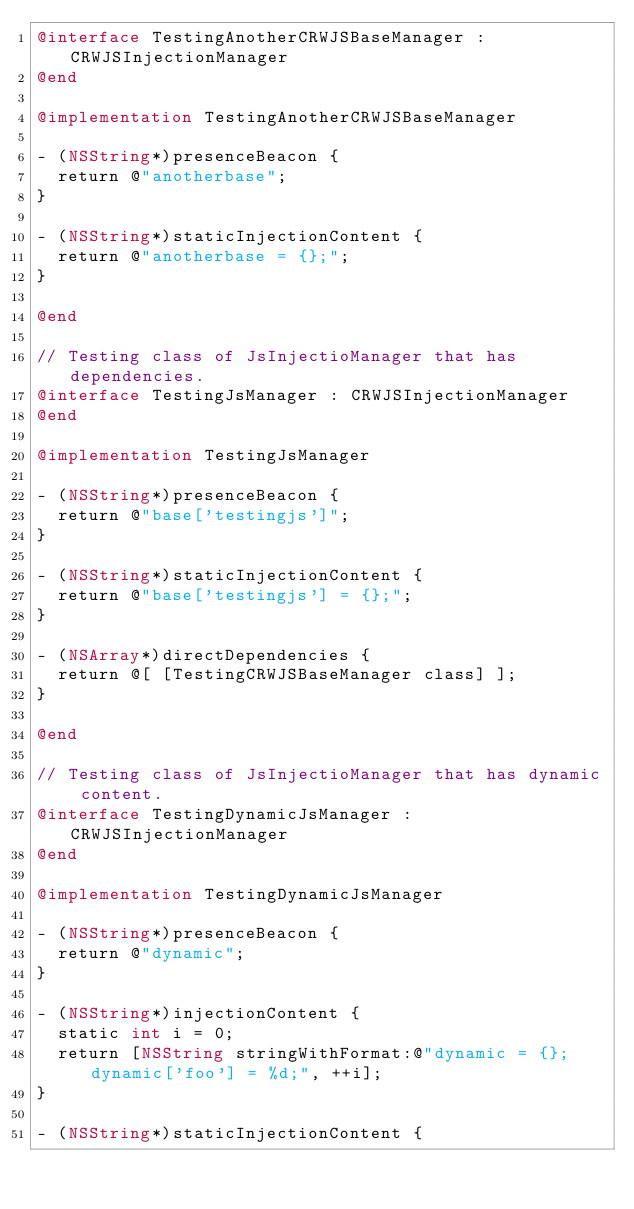Convert code to text. <code><loc_0><loc_0><loc_500><loc_500><_ObjectiveC_>@interface TestingAnotherCRWJSBaseManager : CRWJSInjectionManager
@end

@implementation TestingAnotherCRWJSBaseManager

- (NSString*)presenceBeacon {
  return @"anotherbase";
}

- (NSString*)staticInjectionContent {
  return @"anotherbase = {};";
}

@end

// Testing class of JsInjectioManager that has dependencies.
@interface TestingJsManager : CRWJSInjectionManager
@end

@implementation TestingJsManager

- (NSString*)presenceBeacon {
  return @"base['testingjs']";
}

- (NSString*)staticInjectionContent {
  return @"base['testingjs'] = {};";
}

- (NSArray*)directDependencies {
  return @[ [TestingCRWJSBaseManager class] ];
}

@end

// Testing class of JsInjectioManager that has dynamic content.
@interface TestingDynamicJsManager : CRWJSInjectionManager
@end

@implementation TestingDynamicJsManager

- (NSString*)presenceBeacon {
  return @"dynamic";
}

- (NSString*)injectionContent {
  static int i = 0;
  return [NSString stringWithFormat:@"dynamic = {}; dynamic['foo'] = %d;", ++i];
}

- (NSString*)staticInjectionContent {</code> 